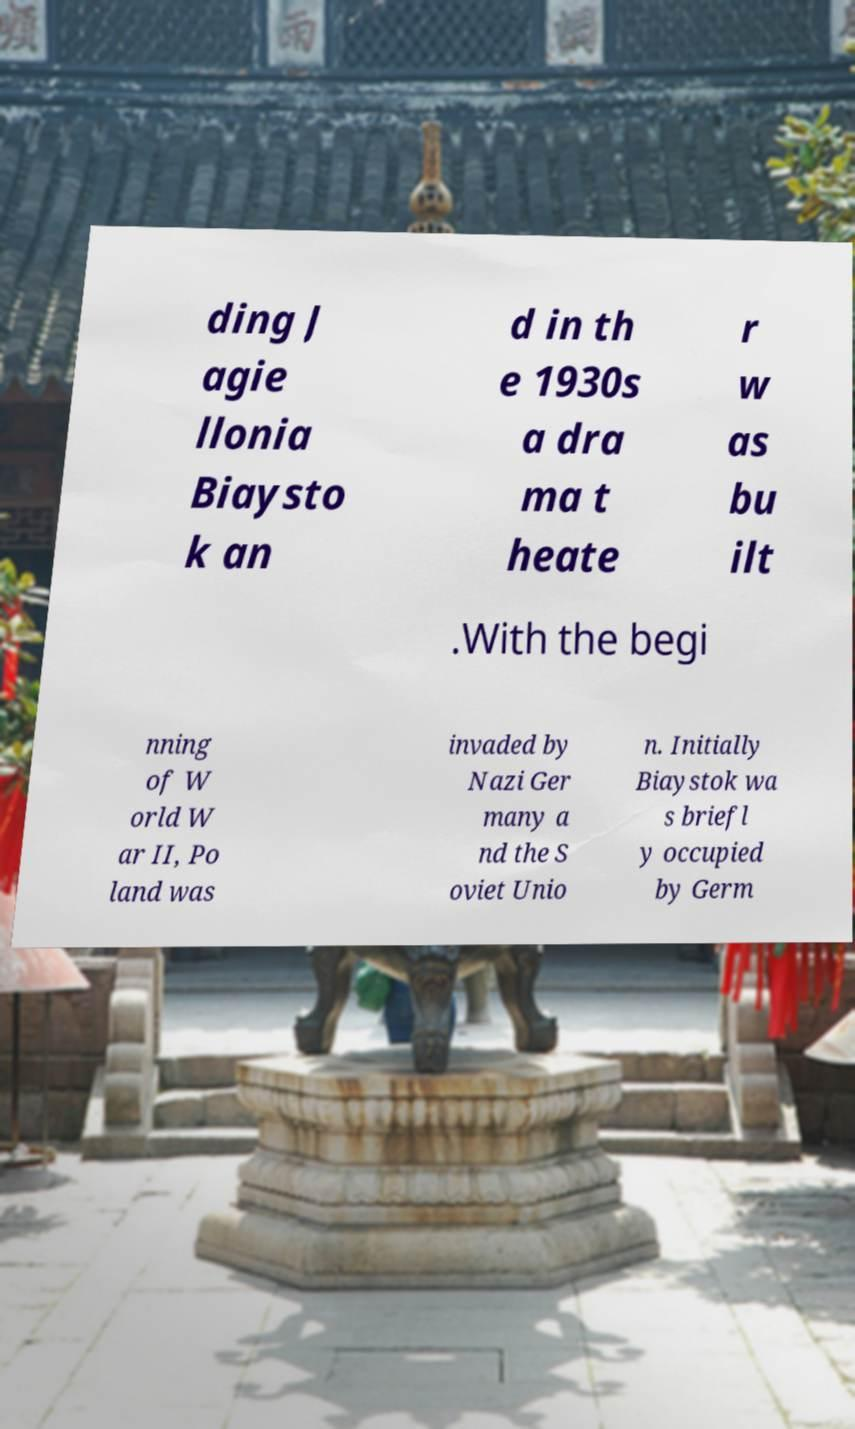Can you accurately transcribe the text from the provided image for me? ding J agie llonia Biaysto k an d in th e 1930s a dra ma t heate r w as bu ilt .With the begi nning of W orld W ar II, Po land was invaded by Nazi Ger many a nd the S oviet Unio n. Initially Biaystok wa s briefl y occupied by Germ 